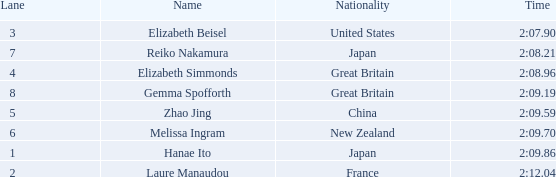What is elizabeth simmonds' mean lane number? 4.0. 